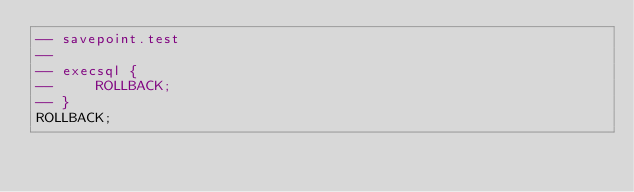<code> <loc_0><loc_0><loc_500><loc_500><_SQL_>-- savepoint.test
-- 
-- execsql {
--     ROLLBACK;
-- }
ROLLBACK;</code> 